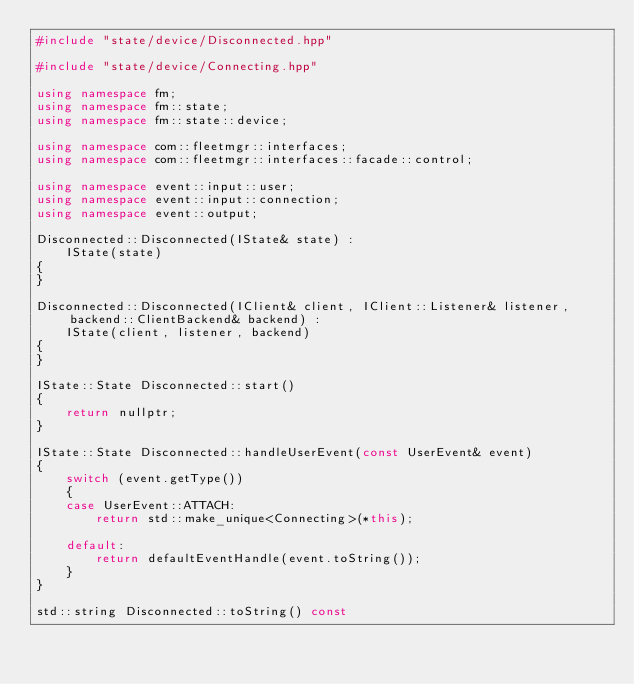Convert code to text. <code><loc_0><loc_0><loc_500><loc_500><_C++_>#include "state/device/Disconnected.hpp"

#include "state/device/Connecting.hpp"

using namespace fm;
using namespace fm::state;
using namespace fm::state::device;

using namespace com::fleetmgr::interfaces;
using namespace com::fleetmgr::interfaces::facade::control;

using namespace event::input::user;
using namespace event::input::connection;
using namespace event::output;

Disconnected::Disconnected(IState& state) :
    IState(state)
{
}

Disconnected::Disconnected(IClient& client, IClient::Listener& listener, backend::ClientBackend& backend) :
    IState(client, listener, backend)
{
}

IState::State Disconnected::start()
{
    return nullptr;
}

IState::State Disconnected::handleUserEvent(const UserEvent& event)
{
    switch (event.getType())
    {
    case UserEvent::ATTACH:
        return std::make_unique<Connecting>(*this);

    default:
        return defaultEventHandle(event.toString());
    }
}

std::string Disconnected::toString() const</code> 